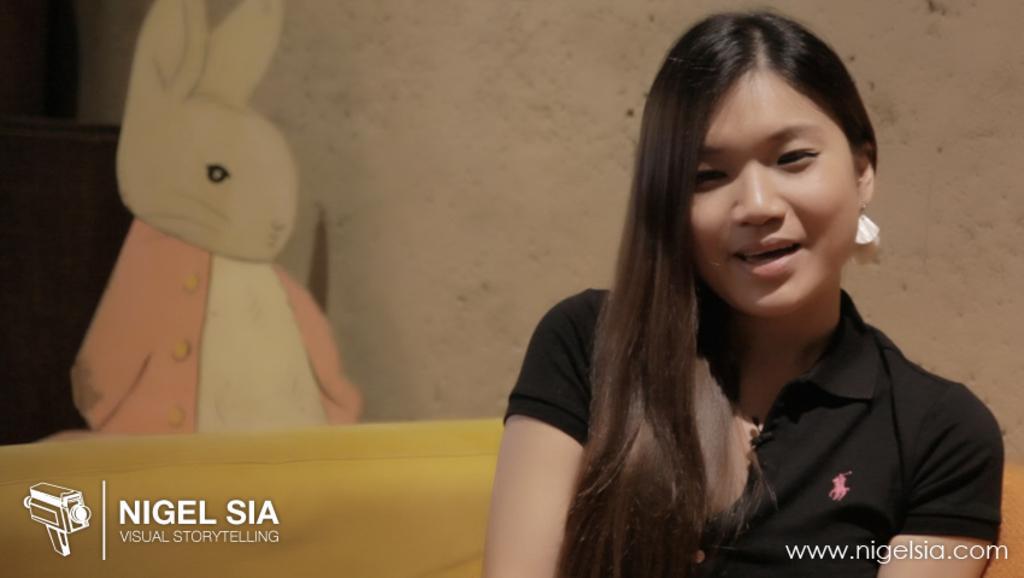How would you summarize this image in a sentence or two? In this picture I can see a woman sitting and a wall in the background. I can see a cartoon image on the left side and text at the bottom left and bottom right corners of the picture. 